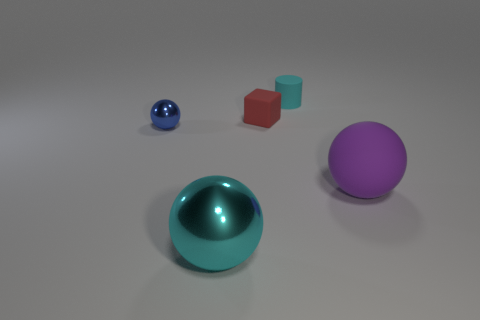How many other things are there of the same color as the rubber sphere?
Your answer should be compact. 0. There is a metallic ball right of the tiny blue object; is it the same color as the cylinder?
Your answer should be very brief. Yes. How many objects are purple rubber things or tiny metallic objects?
Your answer should be compact. 2. There is a ball that is on the right side of the big cyan sphere; what is its color?
Offer a very short reply. Purple. Are there fewer big spheres that are on the right side of the big rubber object than big cyan blocks?
Offer a very short reply. No. There is a sphere that is the same color as the cylinder; what size is it?
Give a very brief answer. Large. Do the small red cube and the blue ball have the same material?
Your answer should be compact. No. How many things are either big balls that are on the right side of the small cylinder or balls on the right side of the tiny rubber block?
Ensure brevity in your answer.  1. Are there any brown metal spheres that have the same size as the rubber block?
Offer a terse response. No. There is a matte object that is the same shape as the blue shiny thing; what is its color?
Give a very brief answer. Purple. 